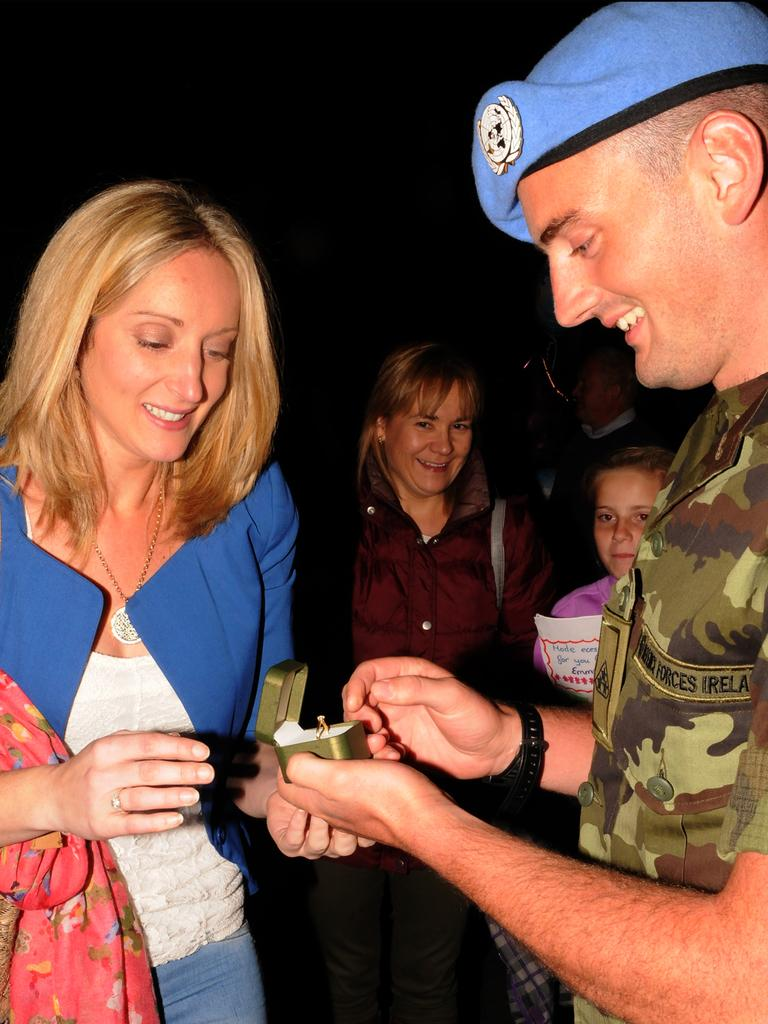How many people are in the image? There are people in the image, but the exact number is not specified. What are some of the people doing in the image? Some of the people are standing in the image. What expressions do some of the people have in the image? Some of the people are smiling in the image. What type of thread is being used to create a pattern on the lamp in the image? There is no lamp or thread present in the image; it only features people. How can you tell that the room is quiet in the image? The image does not provide any information about the noise level or the presence of a room, so it cannot be determined if the room is quiet or not. 